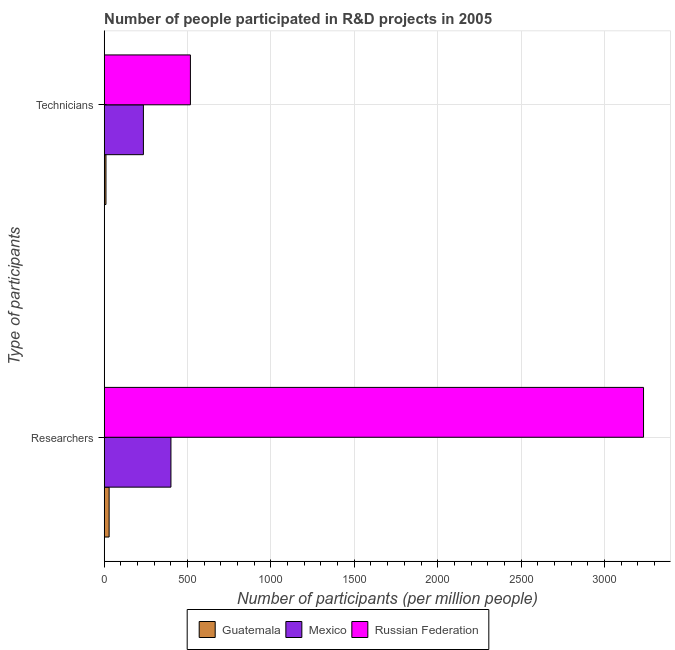How many different coloured bars are there?
Offer a terse response. 3. Are the number of bars per tick equal to the number of legend labels?
Your response must be concise. Yes. Are the number of bars on each tick of the Y-axis equal?
Ensure brevity in your answer.  Yes. How many bars are there on the 2nd tick from the top?
Offer a terse response. 3. What is the label of the 1st group of bars from the top?
Provide a succinct answer. Technicians. What is the number of researchers in Russian Federation?
Your answer should be compact. 3234.71. Across all countries, what is the maximum number of technicians?
Provide a succinct answer. 517. Across all countries, what is the minimum number of researchers?
Keep it short and to the point. 29.43. In which country was the number of researchers maximum?
Give a very brief answer. Russian Federation. In which country was the number of technicians minimum?
Your answer should be compact. Guatemala. What is the total number of technicians in the graph?
Your answer should be very brief. 762.59. What is the difference between the number of technicians in Mexico and that in Guatemala?
Your answer should be compact. 224.5. What is the difference between the number of researchers in Guatemala and the number of technicians in Mexico?
Make the answer very short. -205.62. What is the average number of technicians per country?
Ensure brevity in your answer.  254.2. What is the difference between the number of researchers and number of technicians in Guatemala?
Provide a short and direct response. 18.89. What is the ratio of the number of researchers in Mexico to that in Guatemala?
Offer a terse response. 13.6. Is the number of technicians in Guatemala less than that in Russian Federation?
Provide a succinct answer. Yes. What does the 3rd bar from the top in Researchers represents?
Your answer should be compact. Guatemala. What does the 3rd bar from the bottom in Researchers represents?
Keep it short and to the point. Russian Federation. How many bars are there?
Ensure brevity in your answer.  6. How many countries are there in the graph?
Provide a short and direct response. 3. What is the difference between two consecutive major ticks on the X-axis?
Offer a very short reply. 500. Are the values on the major ticks of X-axis written in scientific E-notation?
Ensure brevity in your answer.  No. Does the graph contain any zero values?
Make the answer very short. No. Does the graph contain grids?
Ensure brevity in your answer.  Yes. What is the title of the graph?
Your answer should be very brief. Number of people participated in R&D projects in 2005. What is the label or title of the X-axis?
Your response must be concise. Number of participants (per million people). What is the label or title of the Y-axis?
Your response must be concise. Type of participants. What is the Number of participants (per million people) in Guatemala in Researchers?
Offer a very short reply. 29.43. What is the Number of participants (per million people) of Mexico in Researchers?
Offer a terse response. 400.21. What is the Number of participants (per million people) of Russian Federation in Researchers?
Give a very brief answer. 3234.71. What is the Number of participants (per million people) in Guatemala in Technicians?
Ensure brevity in your answer.  10.54. What is the Number of participants (per million people) of Mexico in Technicians?
Your answer should be compact. 235.05. What is the Number of participants (per million people) of Russian Federation in Technicians?
Make the answer very short. 517. Across all Type of participants, what is the maximum Number of participants (per million people) of Guatemala?
Make the answer very short. 29.43. Across all Type of participants, what is the maximum Number of participants (per million people) in Mexico?
Your response must be concise. 400.21. Across all Type of participants, what is the maximum Number of participants (per million people) in Russian Federation?
Offer a very short reply. 3234.71. Across all Type of participants, what is the minimum Number of participants (per million people) in Guatemala?
Your answer should be very brief. 10.54. Across all Type of participants, what is the minimum Number of participants (per million people) in Mexico?
Keep it short and to the point. 235.05. Across all Type of participants, what is the minimum Number of participants (per million people) in Russian Federation?
Provide a short and direct response. 517. What is the total Number of participants (per million people) of Guatemala in the graph?
Provide a short and direct response. 39.97. What is the total Number of participants (per million people) of Mexico in the graph?
Give a very brief answer. 635.26. What is the total Number of participants (per million people) in Russian Federation in the graph?
Keep it short and to the point. 3751.71. What is the difference between the Number of participants (per million people) in Guatemala in Researchers and that in Technicians?
Keep it short and to the point. 18.89. What is the difference between the Number of participants (per million people) of Mexico in Researchers and that in Technicians?
Provide a short and direct response. 165.16. What is the difference between the Number of participants (per million people) of Russian Federation in Researchers and that in Technicians?
Your answer should be compact. 2717.71. What is the difference between the Number of participants (per million people) of Guatemala in Researchers and the Number of participants (per million people) of Mexico in Technicians?
Give a very brief answer. -205.62. What is the difference between the Number of participants (per million people) in Guatemala in Researchers and the Number of participants (per million people) in Russian Federation in Technicians?
Your response must be concise. -487.57. What is the difference between the Number of participants (per million people) in Mexico in Researchers and the Number of participants (per million people) in Russian Federation in Technicians?
Offer a very short reply. -116.79. What is the average Number of participants (per million people) of Guatemala per Type of participants?
Offer a terse response. 19.99. What is the average Number of participants (per million people) of Mexico per Type of participants?
Keep it short and to the point. 317.63. What is the average Number of participants (per million people) in Russian Federation per Type of participants?
Offer a terse response. 1875.85. What is the difference between the Number of participants (per million people) of Guatemala and Number of participants (per million people) of Mexico in Researchers?
Give a very brief answer. -370.78. What is the difference between the Number of participants (per million people) of Guatemala and Number of participants (per million people) of Russian Federation in Researchers?
Ensure brevity in your answer.  -3205.28. What is the difference between the Number of participants (per million people) in Mexico and Number of participants (per million people) in Russian Federation in Researchers?
Ensure brevity in your answer.  -2834.5. What is the difference between the Number of participants (per million people) of Guatemala and Number of participants (per million people) of Mexico in Technicians?
Provide a succinct answer. -224.5. What is the difference between the Number of participants (per million people) of Guatemala and Number of participants (per million people) of Russian Federation in Technicians?
Your answer should be very brief. -506.46. What is the difference between the Number of participants (per million people) in Mexico and Number of participants (per million people) in Russian Federation in Technicians?
Offer a very short reply. -281.95. What is the ratio of the Number of participants (per million people) of Guatemala in Researchers to that in Technicians?
Your answer should be compact. 2.79. What is the ratio of the Number of participants (per million people) in Mexico in Researchers to that in Technicians?
Your answer should be compact. 1.7. What is the ratio of the Number of participants (per million people) in Russian Federation in Researchers to that in Technicians?
Offer a very short reply. 6.26. What is the difference between the highest and the second highest Number of participants (per million people) of Guatemala?
Your answer should be very brief. 18.89. What is the difference between the highest and the second highest Number of participants (per million people) of Mexico?
Ensure brevity in your answer.  165.16. What is the difference between the highest and the second highest Number of participants (per million people) of Russian Federation?
Ensure brevity in your answer.  2717.71. What is the difference between the highest and the lowest Number of participants (per million people) in Guatemala?
Your answer should be compact. 18.89. What is the difference between the highest and the lowest Number of participants (per million people) of Mexico?
Provide a succinct answer. 165.16. What is the difference between the highest and the lowest Number of participants (per million people) of Russian Federation?
Provide a short and direct response. 2717.71. 